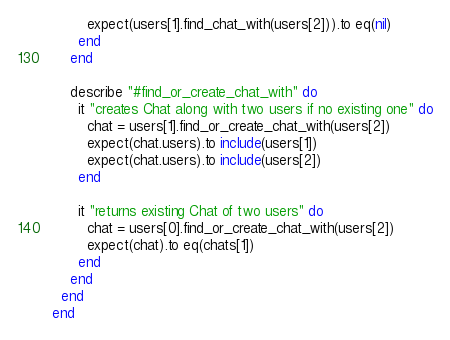Convert code to text. <code><loc_0><loc_0><loc_500><loc_500><_Ruby_>        expect(users[1].find_chat_with(users[2])).to eq(nil)
      end
    end

    describe "#find_or_create_chat_with" do
      it "creates Chat along with two users if no existing one" do
        chat = users[1].find_or_create_chat_with(users[2])
        expect(chat.users).to include(users[1])
        expect(chat.users).to include(users[2])
      end

      it "returns existing Chat of two users" do
        chat = users[0].find_or_create_chat_with(users[2])
        expect(chat).to eq(chats[1])
      end
    end
  end
end
</code> 